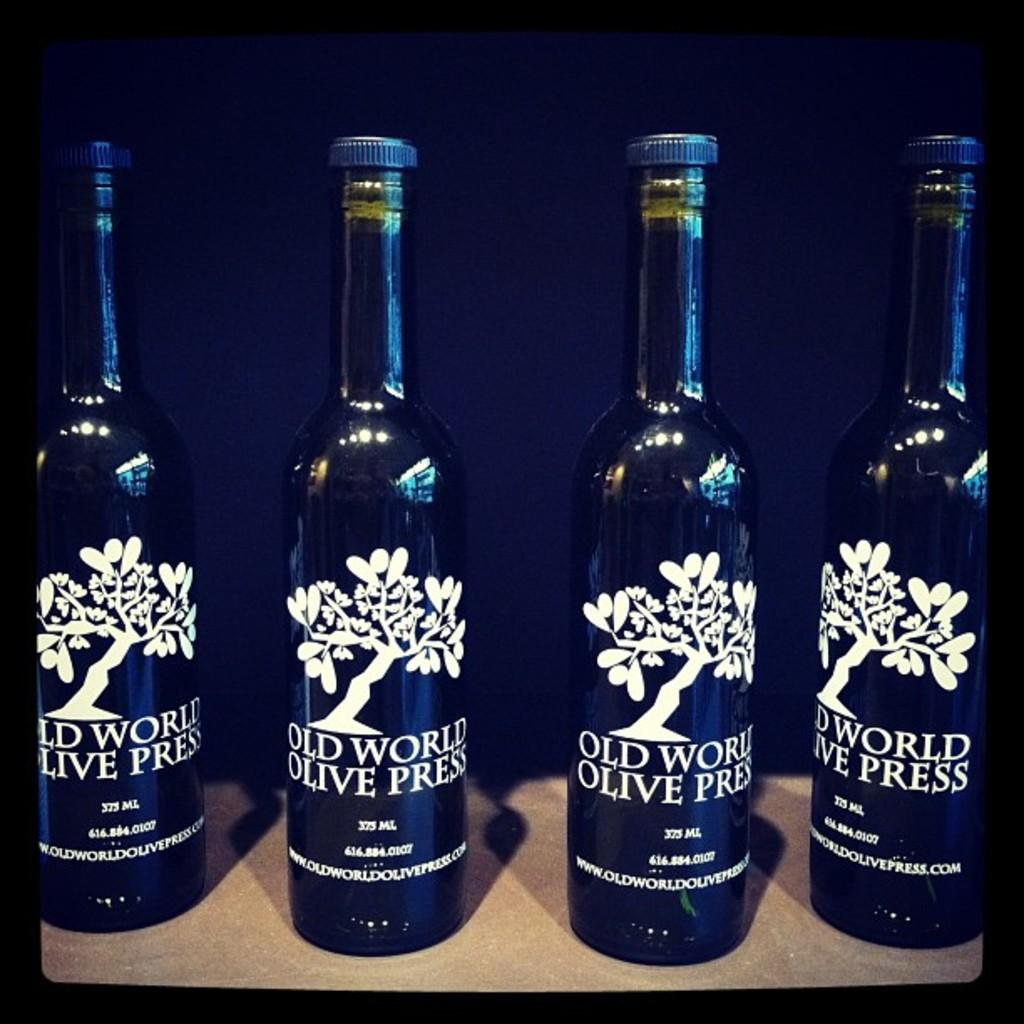<image>
Give a short and clear explanation of the subsequent image. Four bottles of Old World Olive Press are next to each other in a row. 